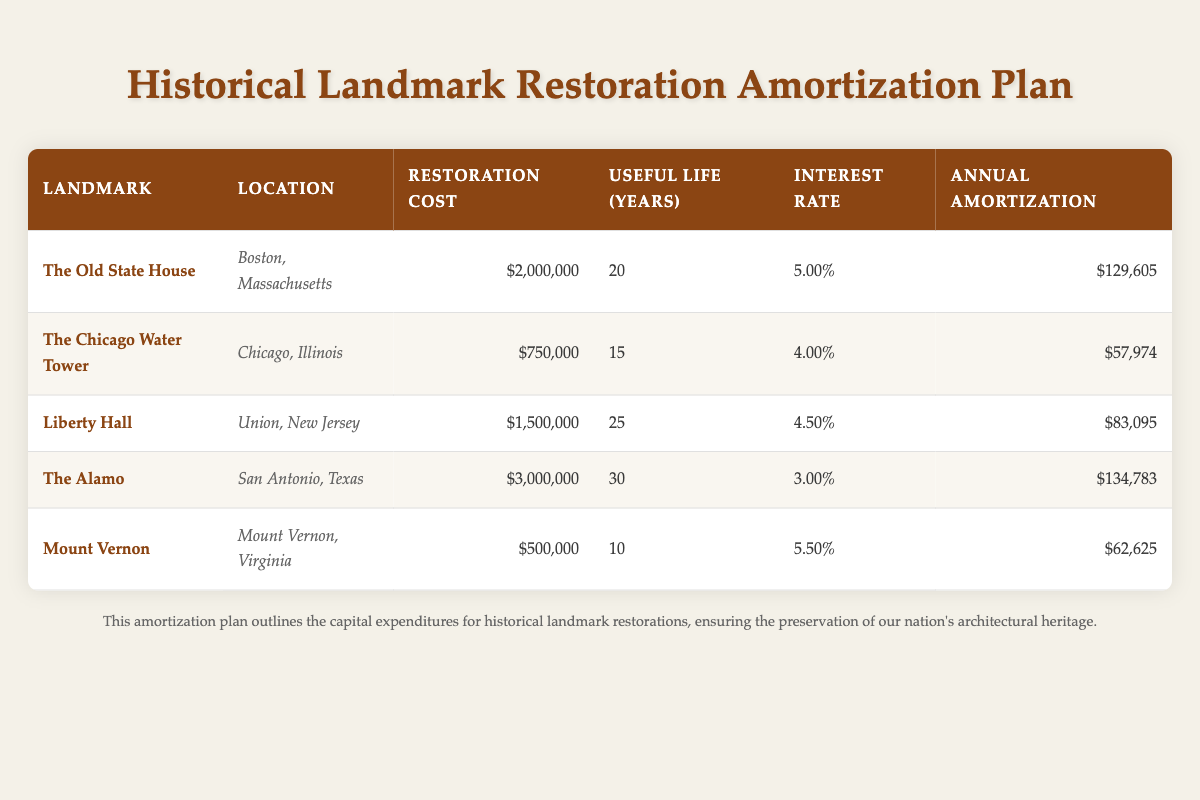What is the restoration cost for Liberty Hall? The table lists the restoration cost for Liberty Hall located in Union, New Jersey, as $1,500,000.
Answer: $1,500,000 Which landmark has the highest annual amortization? By reviewing the annual amortization figures, The Alamo has the highest annual amortization at $134,783.
Answer: The Alamo What is the total restoration cost for all landmarks combined? The total restoration cost can be found by summing up all the individual restoration costs: 2,000,000 + 750,000 + 1,500,000 + 3,000,000 + 500,000 = 8,750,000.
Answer: $8,750,000 Does Mount Vernon have a longer useful life than The Chicago Water Tower? The useful life for Mount Vernon is 10 years, and for The Chicago Water Tower, it is 15 years. Since 10 is less than 15, the statement is false.
Answer: No What is the average annual amortization for all the landmarks listed? To find the average annual amortization, sum the annual amortizations ($129,605 + $57,974 + $83,095 + $134,783 + $62,625) to get $468,082, then divide by the number of landmarks (5): 468,082 / 5 = 93,616.4. The average is approximately $93,616.
Answer: $93,616 